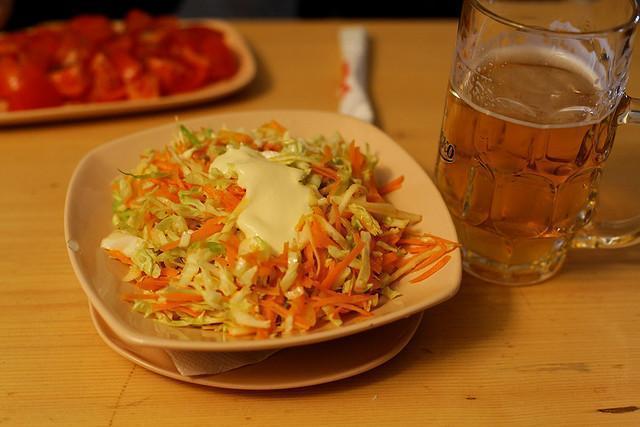How many carrots can be seen?
Give a very brief answer. 3. How many boats can you see in the water?
Give a very brief answer. 0. 